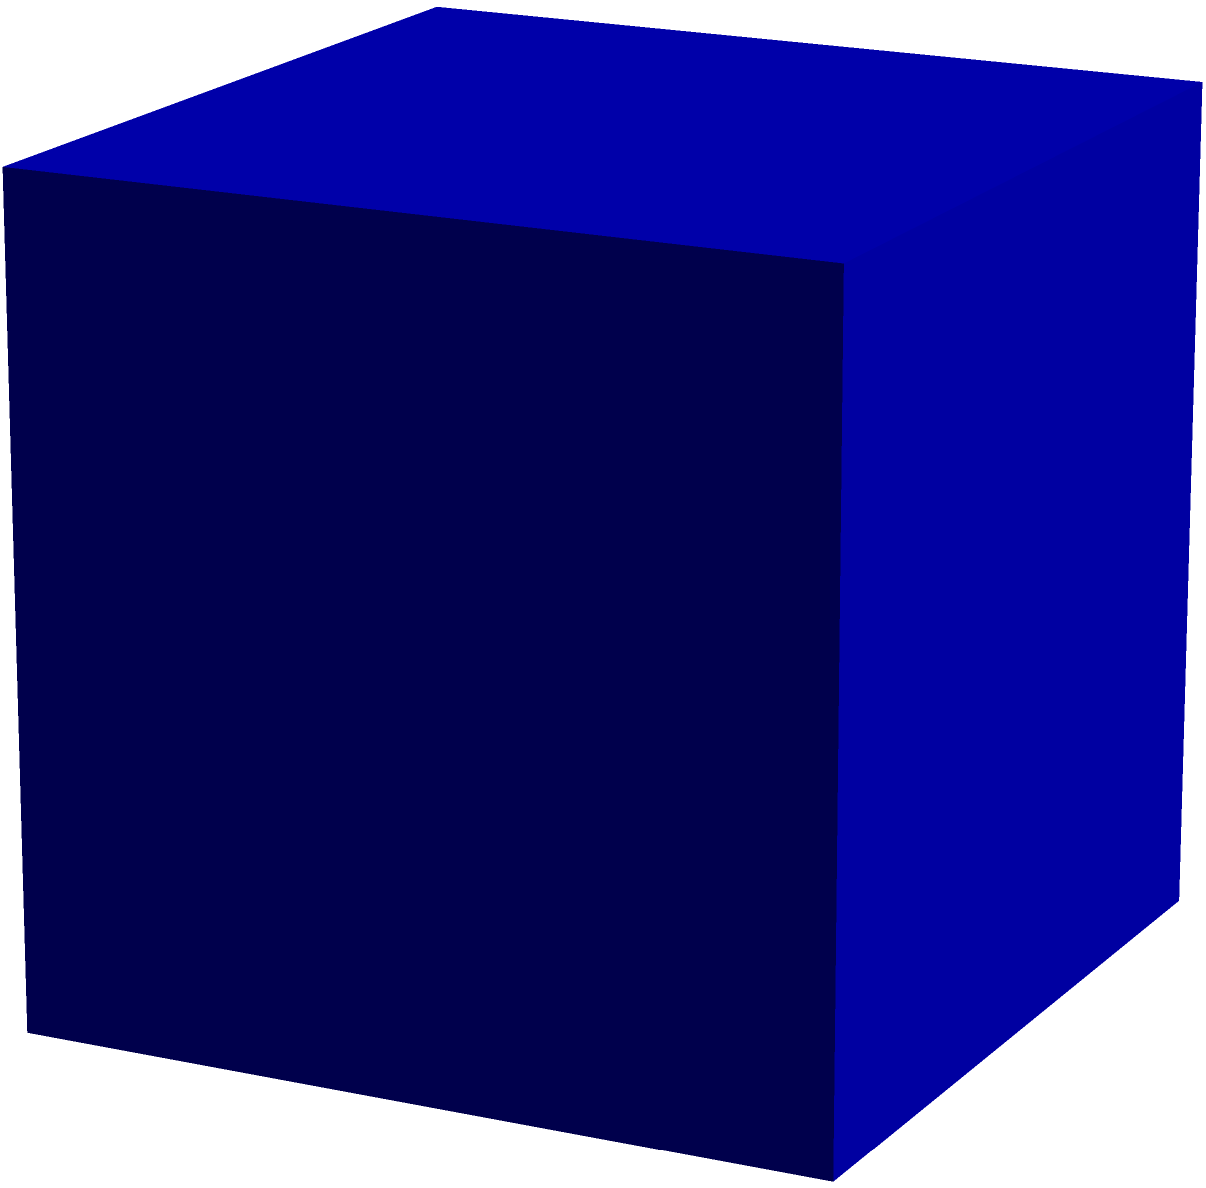A community center is being planned for a neglected urban area. The building will be cube-shaped with each side measuring 15 meters. If the entire exterior surface of the building needs to be painted, what is the total surface area that requires painting? To find the total surface area of the cube-shaped community center, we need to follow these steps:

1. Recall the formula for the surface area of a cube:
   $$SA = 6s^2$$
   where $s$ is the length of one side of the cube.

2. We are given that each side of the cube measures 15 meters.
   Therefore, $s = 15$ m.

3. Let's substitute this value into our formula:
   $$SA = 6 \cdot (15 \text{ m})^2$$

4. Calculate the square of 15:
   $$SA = 6 \cdot (225 \text{ m}^2)$$

5. Multiply:
   $$SA = 1350 \text{ m}^2$$

Therefore, the total surface area that requires painting is 1350 square meters.
Answer: 1350 m² 